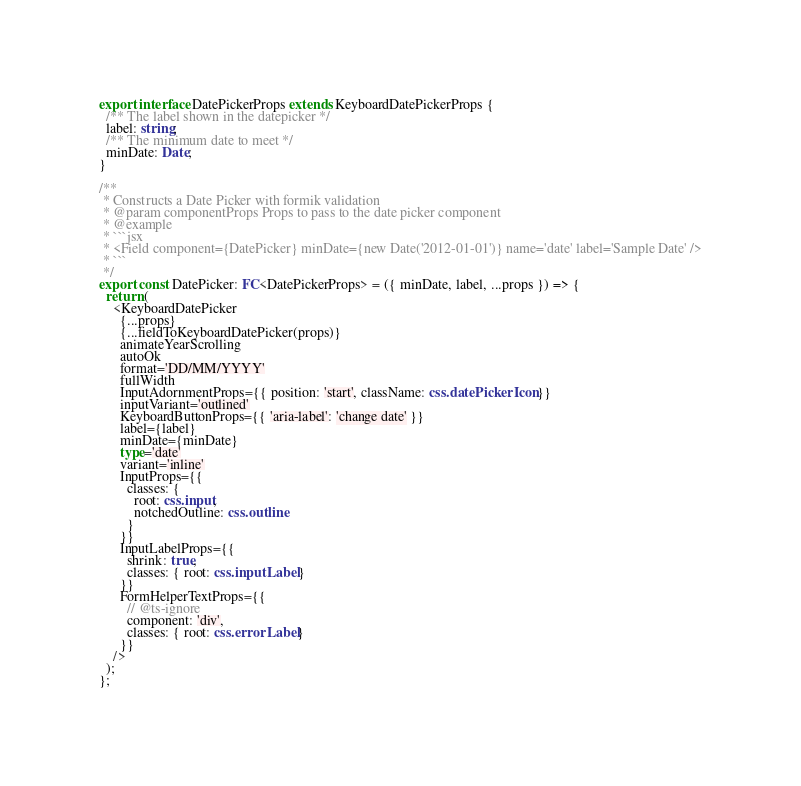<code> <loc_0><loc_0><loc_500><loc_500><_TypeScript_>
export interface DatePickerProps extends KeyboardDatePickerProps {
  /** The label shown in the datepicker */
  label: string;
  /** The minimum date to meet */
  minDate: Date;
}

/**
 * Constructs a Date Picker with formik validation
 * @param componentProps Props to pass to the date picker component
 * @example
 * ```jsx
 * <Field component={DatePicker} minDate={new Date('2012-01-01')} name='date' label='Sample Date' />
 * ```
 */
export const DatePicker: FC<DatePickerProps> = ({ minDate, label, ...props }) => {
  return (
    <KeyboardDatePicker
      {...props}
      {...fieldToKeyboardDatePicker(props)}
      animateYearScrolling
      autoOk
      format='DD/MM/YYYY'
      fullWidth
      InputAdornmentProps={{ position: 'start', className: css.datePickerIcon }}
      inputVariant='outlined'
      KeyboardButtonProps={{ 'aria-label': 'change date' }}
      label={label}
      minDate={minDate}
      type='date'
      variant='inline'
      InputProps={{
        classes: {
          root: css.input,
          notchedOutline: css.outline
        }
      }}
      InputLabelProps={{
        shrink: true,
        classes: { root: css.inputLabel }
      }}
      FormHelperTextProps={{
        // @ts-ignore
        component: 'div',
        classes: { root: css.errorLabel }
      }}
    />
  );
};
</code> 